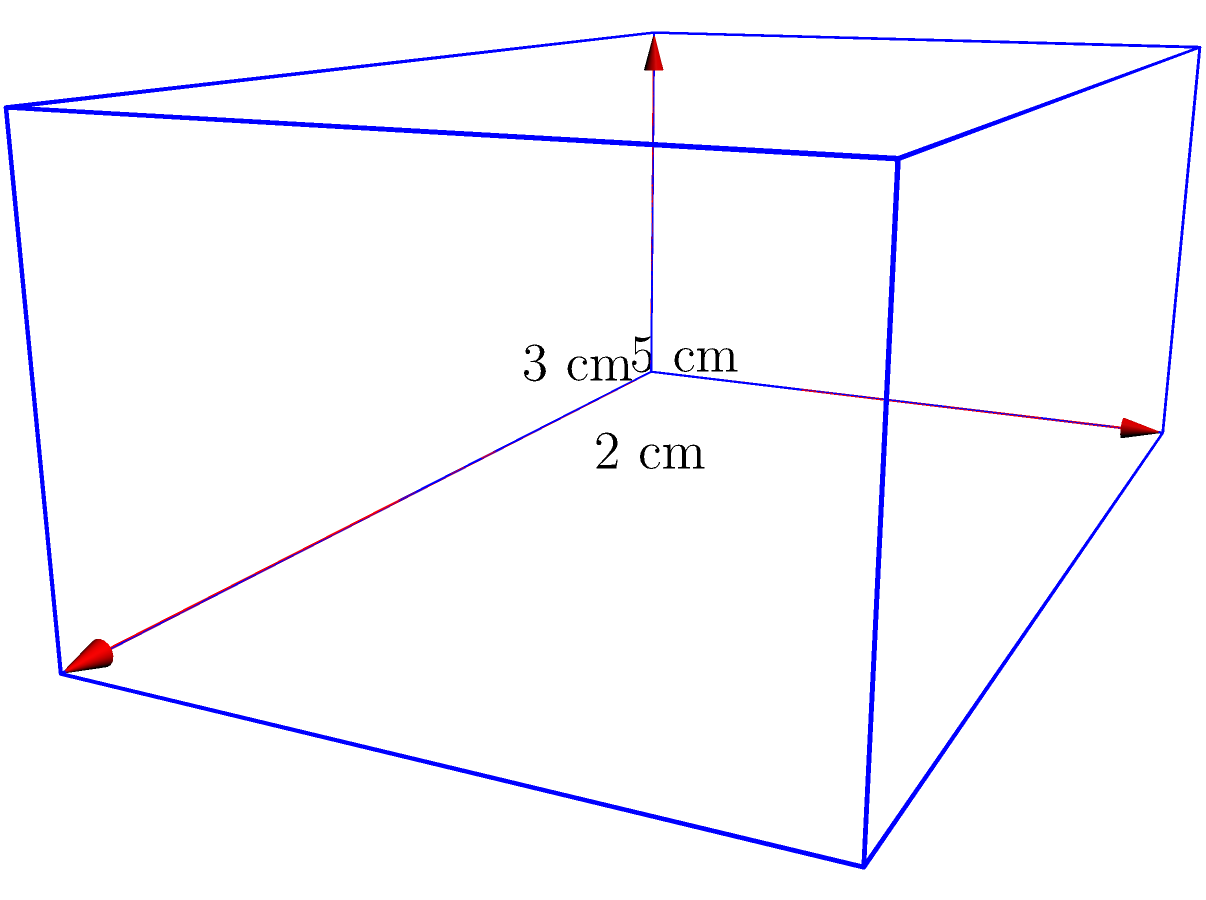As a student athlete, you're preparing a cooler for your upcoming game. The rectangular prism-shaped cooler has dimensions of 5 cm x 3 cm x 2 cm. What is the volume of this cooler in cubic centimeters (cm³)? To calculate the volume of a rectangular prism, we use the formula:

$$V = l \times w \times h$$

Where:
$V$ = volume
$l$ = length
$w$ = width
$h$ = height

Given dimensions:
Length ($l$) = 5 cm
Width ($w$) = 3 cm
Height ($h$) = 2 cm

Substituting these values into the formula:

$$V = 5 \text{ cm} \times 3 \text{ cm} \times 2 \text{ cm}$$

$$V = 30 \text{ cm}^3$$

Therefore, the volume of the cooler is 30 cubic centimeters.
Answer: 30 cm³ 